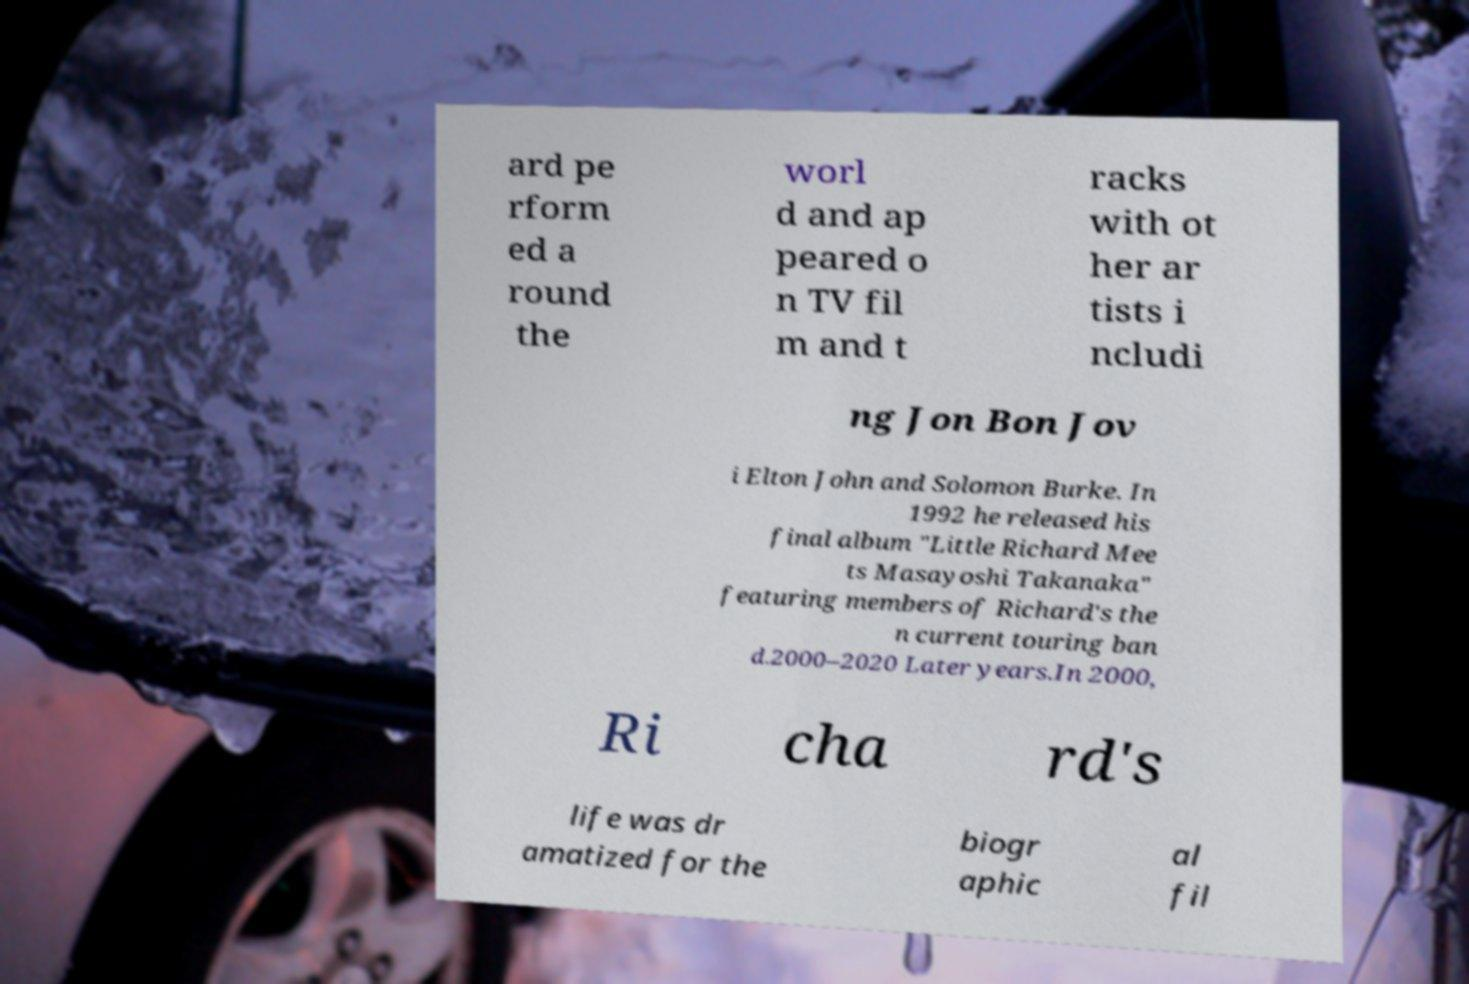What messages or text are displayed in this image? I need them in a readable, typed format. ard pe rform ed a round the worl d and ap peared o n TV fil m and t racks with ot her ar tists i ncludi ng Jon Bon Jov i Elton John and Solomon Burke. In 1992 he released his final album "Little Richard Mee ts Masayoshi Takanaka" featuring members of Richard's the n current touring ban d.2000–2020 Later years.In 2000, Ri cha rd's life was dr amatized for the biogr aphic al fil 